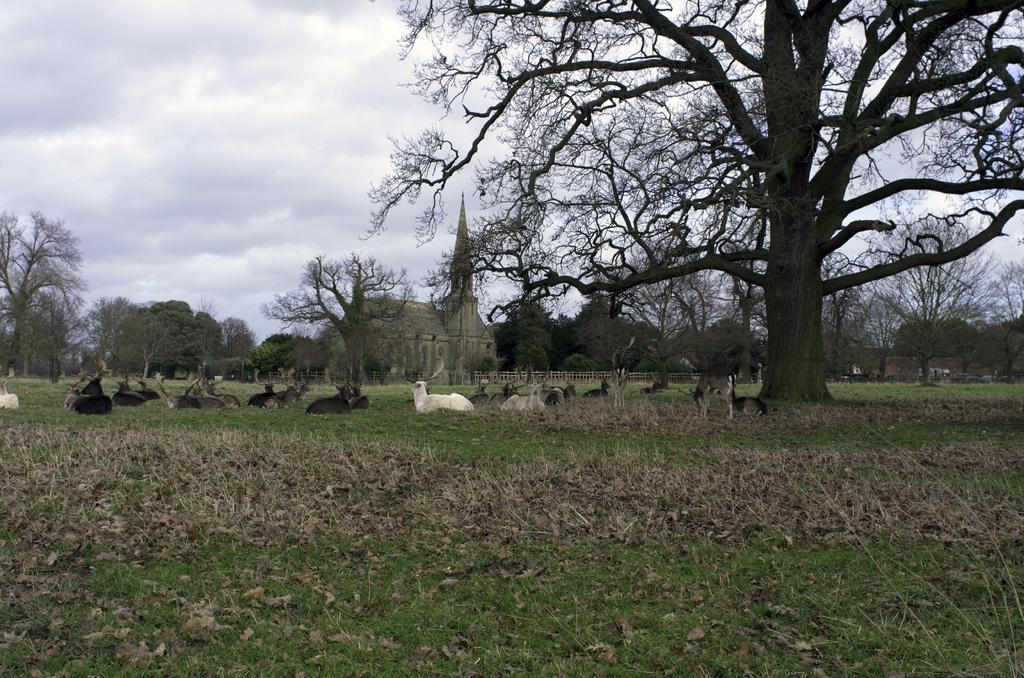Describe this image in one or two sentences. In the image there is a huge tree and under that tree many animals were laying on the grass, behind that garden there is a building and around that there are plenty of trees. 